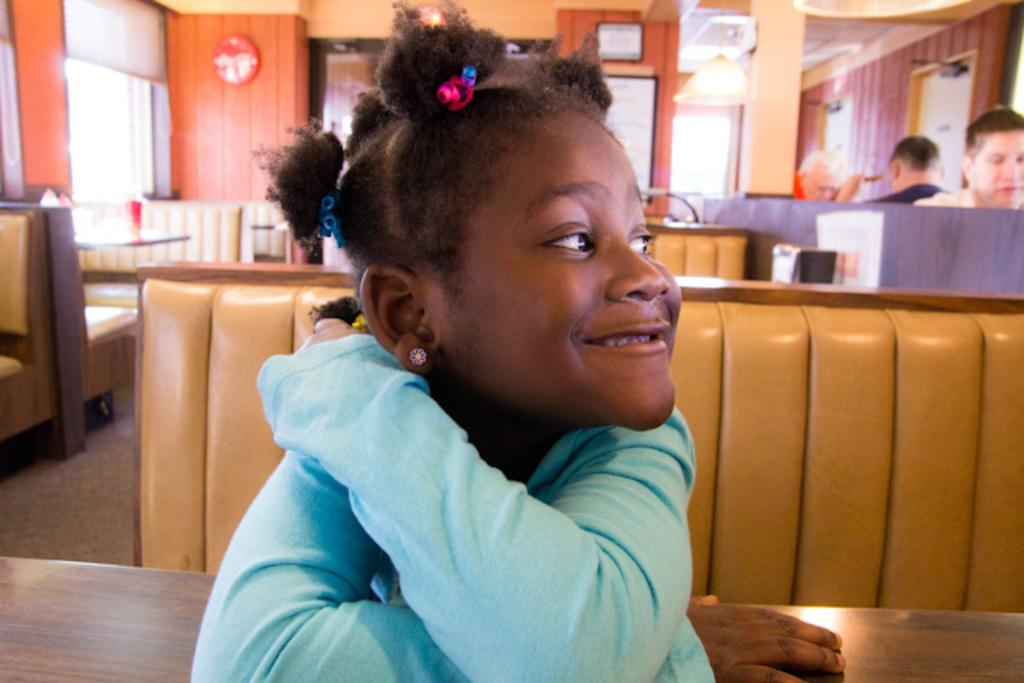Who is the main subject in the image? There is a girl in the image. What is the girl doing in the image? The girl is sitting on a bench and smiling. What can be seen in the background of the image? There are persons, desks, side tables, and wall hangings visible in the background of the image. What type of popcorn is the girl eating in the image? There is no popcorn present in the image; the girl is sitting on a bench and smiling. Can you tell me how many jellyfish are swimming in the background of the image? There are no jellyfish present in the image; the background features persons, desks, side tables, and wall hangings. 